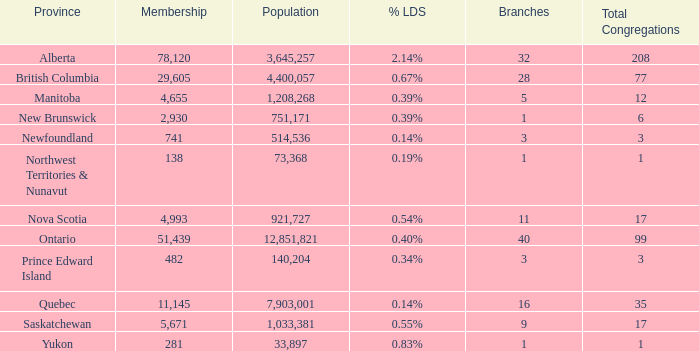What's the sum of the total congregation in the manitoba province with less than 1,208,268 population? None. 